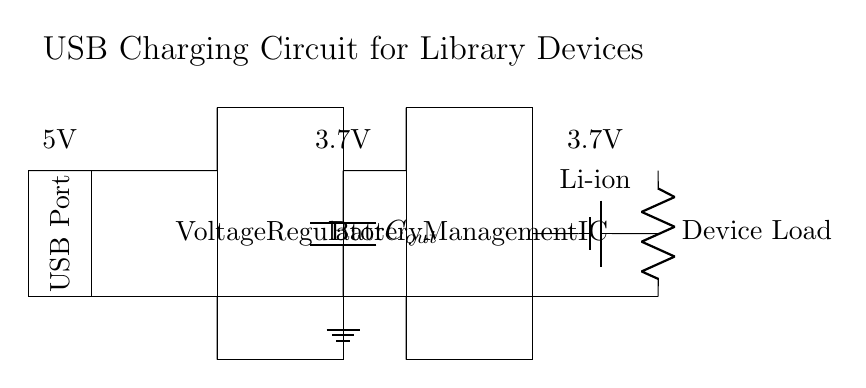What is the output capacitor labeled as? The output capacitor is labeled as C_out in the diagram, indicating its function in the circuit.
Answer: C_out What type of battery is used in this circuit? The circuit uses a lithium-ion battery, indicated specifically by the label "Li-ion" in the diagram.
Answer: Li-ion What voltage does the USB port provide? The USB port provides a voltage of 5V, which is indicated above the port in the diagram.
Answer: 5V Which component regulates the voltage in the circuit? The voltage regulator is responsible for regulating the voltage, as shown in the diagram where it is specifically labeled.
Answer: Voltage Regulator If the device load has a current of 1A, what is the equivalent resistance of the device load considering the voltage at the load? The device load is connected to a voltage of 3.7V as indicated above it. Using Ohm's Law (R = V/I), R = 3.7V / 1A = 3.7 ohms makes the equivalent resistance.
Answer: 3.7 ohms How many main components are involved in this USB charging circuit? The main components visible in the circuit are the USB port, voltage regulator, output capacitor, battery management IC, lithium-ion battery, and the device load. This gives a total of six main components.
Answer: 6 